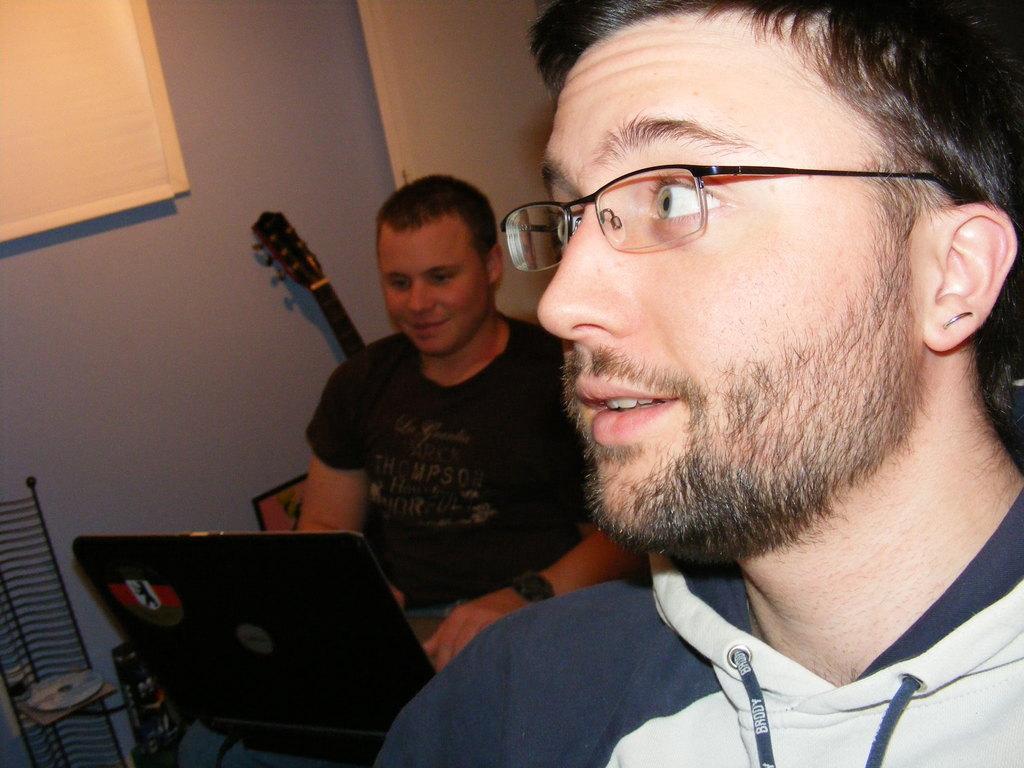In one or two sentences, can you explain what this image depicts? In this image we can see two persons. One person is wearing spectacles. One person is looking at a laptop. In the background, we can see a guitar, photo frame on the wall, disk placed on a rack, window and a door. 